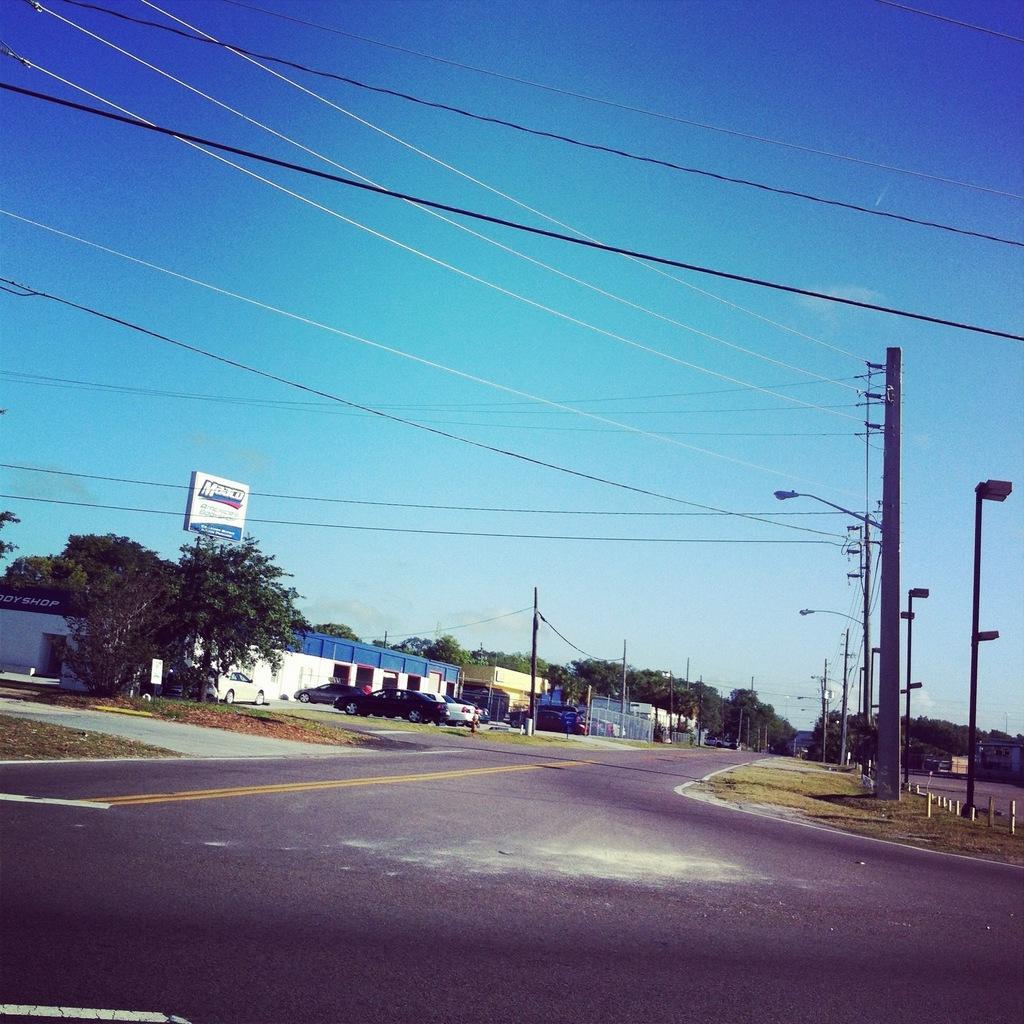Can you describe this image briefly? In this image we can see the trees, light poles, electrical poles with wires and also the barrier rods. We can also see the empty road, grass, vehicles and also the buildings. We can also see a hoarding. In the background, we can see the sky. 